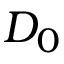Convert formula to latex. <formula><loc_0><loc_0><loc_500><loc_500>D _ { 0 }</formula> 